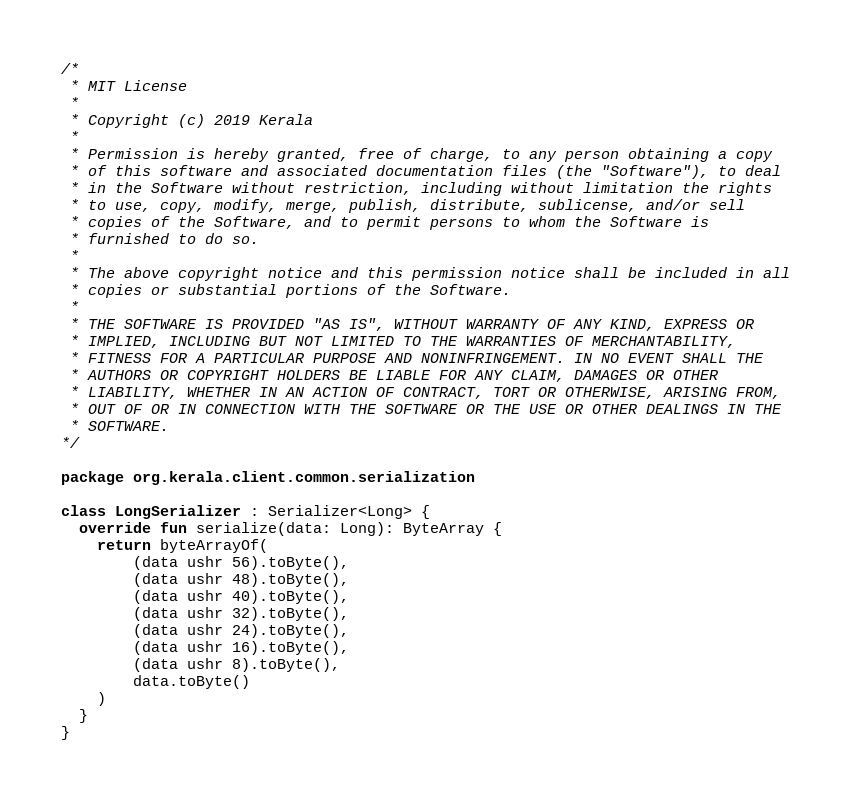Convert code to text. <code><loc_0><loc_0><loc_500><loc_500><_Kotlin_>/*
 * MIT License
 *
 * Copyright (c) 2019 Kerala
 *
 * Permission is hereby granted, free of charge, to any person obtaining a copy
 * of this software and associated documentation files (the "Software"), to deal
 * in the Software without restriction, including without limitation the rights
 * to use, copy, modify, merge, publish, distribute, sublicense, and/or sell
 * copies of the Software, and to permit persons to whom the Software is
 * furnished to do so.
 *
 * The above copyright notice and this permission notice shall be included in all
 * copies or substantial portions of the Software.
 *
 * THE SOFTWARE IS PROVIDED "AS IS", WITHOUT WARRANTY OF ANY KIND, EXPRESS OR
 * IMPLIED, INCLUDING BUT NOT LIMITED TO THE WARRANTIES OF MERCHANTABILITY,
 * FITNESS FOR A PARTICULAR PURPOSE AND NONINFRINGEMENT. IN NO EVENT SHALL THE
 * AUTHORS OR COPYRIGHT HOLDERS BE LIABLE FOR ANY CLAIM, DAMAGES OR OTHER
 * LIABILITY, WHETHER IN AN ACTION OF CONTRACT, TORT OR OTHERWISE, ARISING FROM,
 * OUT OF OR IN CONNECTION WITH THE SOFTWARE OR THE USE OR OTHER DEALINGS IN THE
 * SOFTWARE.
*/

package org.kerala.client.common.serialization

class LongSerializer : Serializer<Long> {
  override fun serialize(data: Long): ByteArray {
    return byteArrayOf(
        (data ushr 56).toByte(),
        (data ushr 48).toByte(),
        (data ushr 40).toByte(),
        (data ushr 32).toByte(),
        (data ushr 24).toByte(),
        (data ushr 16).toByte(),
        (data ushr 8).toByte(),
        data.toByte()
    )
  }
}
</code> 